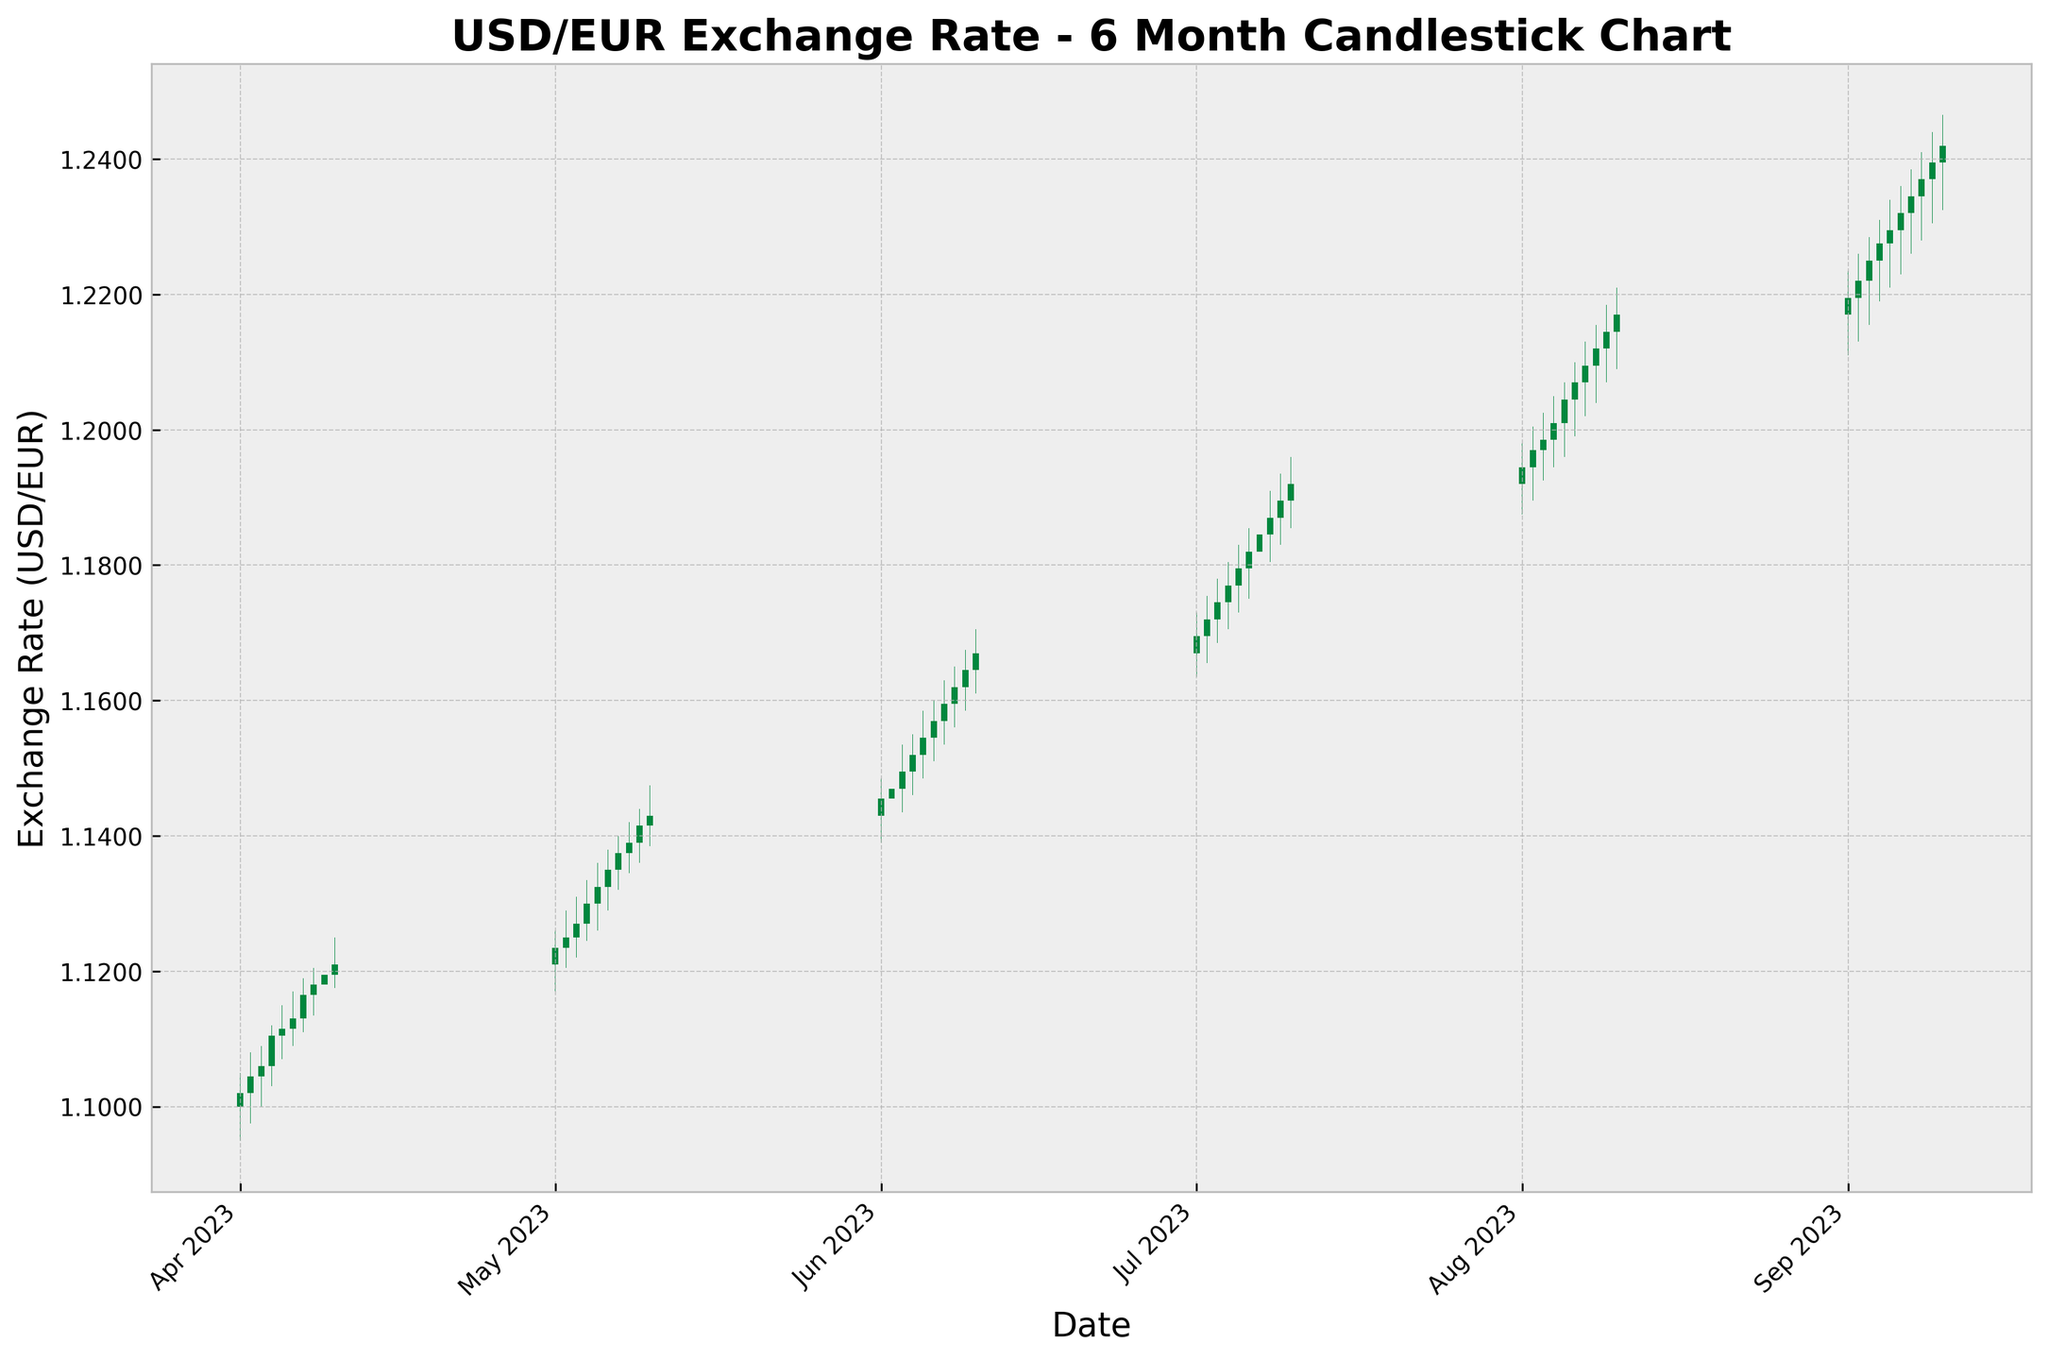What's the title of the plot? The title of the plot can be easily found at the top of the figure, where it's prominently displayed. The title helps in identifying what the plot is about.
Answer: USD/EUR Exchange Rate - 6 Month Candlestick Chart How many months' worth of data is shown in the plot? To determine the number of months, look at the x-axis, which is formatted with monthly ticks. Count the number of unique month labels.
Answer: 6 Which month shows the highest exchange rate for USD/EUR? Identify the months displayed on the x-axis and examine the candlesticks within each month for their high points. The highest point on a candlestick within a month represents the highest exchange rate.
Answer: September What was the highest USD/EUR exchange rate in September 2023? Focus on the candlesticks in September and find the one that has the highest upper wick (the line extending from the body). This represents the highest exchange rate.
Answer: 1.2465 Is there a general trend in the exchange rate from April to September? Observe the general direction of the candlesticks from April to September. If they mostly move upward, the trend is increasing; if downward, decreasing.
Answer: Increasing Which days in April had the highest closing rates? Focus on the portion of the plot depicting April and examine the closing positions of the green and red candlesticks. Look for the candlesticks that have the highest endpoint (close).
Answer: April 9 and April 10 Which day in August had the largest range between high and low exchange rates? Check the candlesticks for August and compare the lengths of the wicks (high minus low) for each day. Identify the day with the largest range.
Answer: August 4 Did the exchange rate close higher than it opened on September 5, 2023? Find the candlestick corresponding to September 5 and compare the positions of the open and close markers. If the close is higher than the open, the answer is yes.
Answer: Yes 